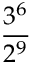Convert formula to latex. <formula><loc_0><loc_0><loc_500><loc_500>\frac { 3 ^ { 6 } } { 2 ^ { 9 } }</formula> 